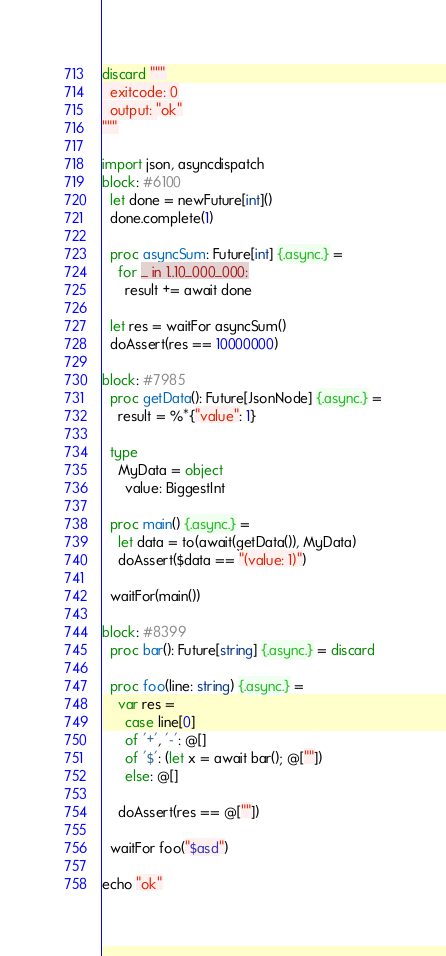<code> <loc_0><loc_0><loc_500><loc_500><_Nim_>discard """
  exitcode: 0
  output: "ok"
"""

import json, asyncdispatch
block: #6100
  let done = newFuture[int]()
  done.complete(1)

  proc asyncSum: Future[int] {.async.} =
    for _ in 1..10_000_000:
      result += await done

  let res = waitFor asyncSum()
  doAssert(res == 10000000)

block: #7985
  proc getData(): Future[JsonNode] {.async.} =
    result = %*{"value": 1}

  type
    MyData = object
      value: BiggestInt

  proc main() {.async.} =
    let data = to(await(getData()), MyData)
    doAssert($data == "(value: 1)")

  waitFor(main())

block: #8399
  proc bar(): Future[string] {.async.} = discard

  proc foo(line: string) {.async.} =
    var res =
      case line[0]
      of '+', '-': @[]
      of '$': (let x = await bar(); @[""])
      else: @[]

    doAssert(res == @[""])

  waitFor foo("$asd")

echo "ok"
</code> 